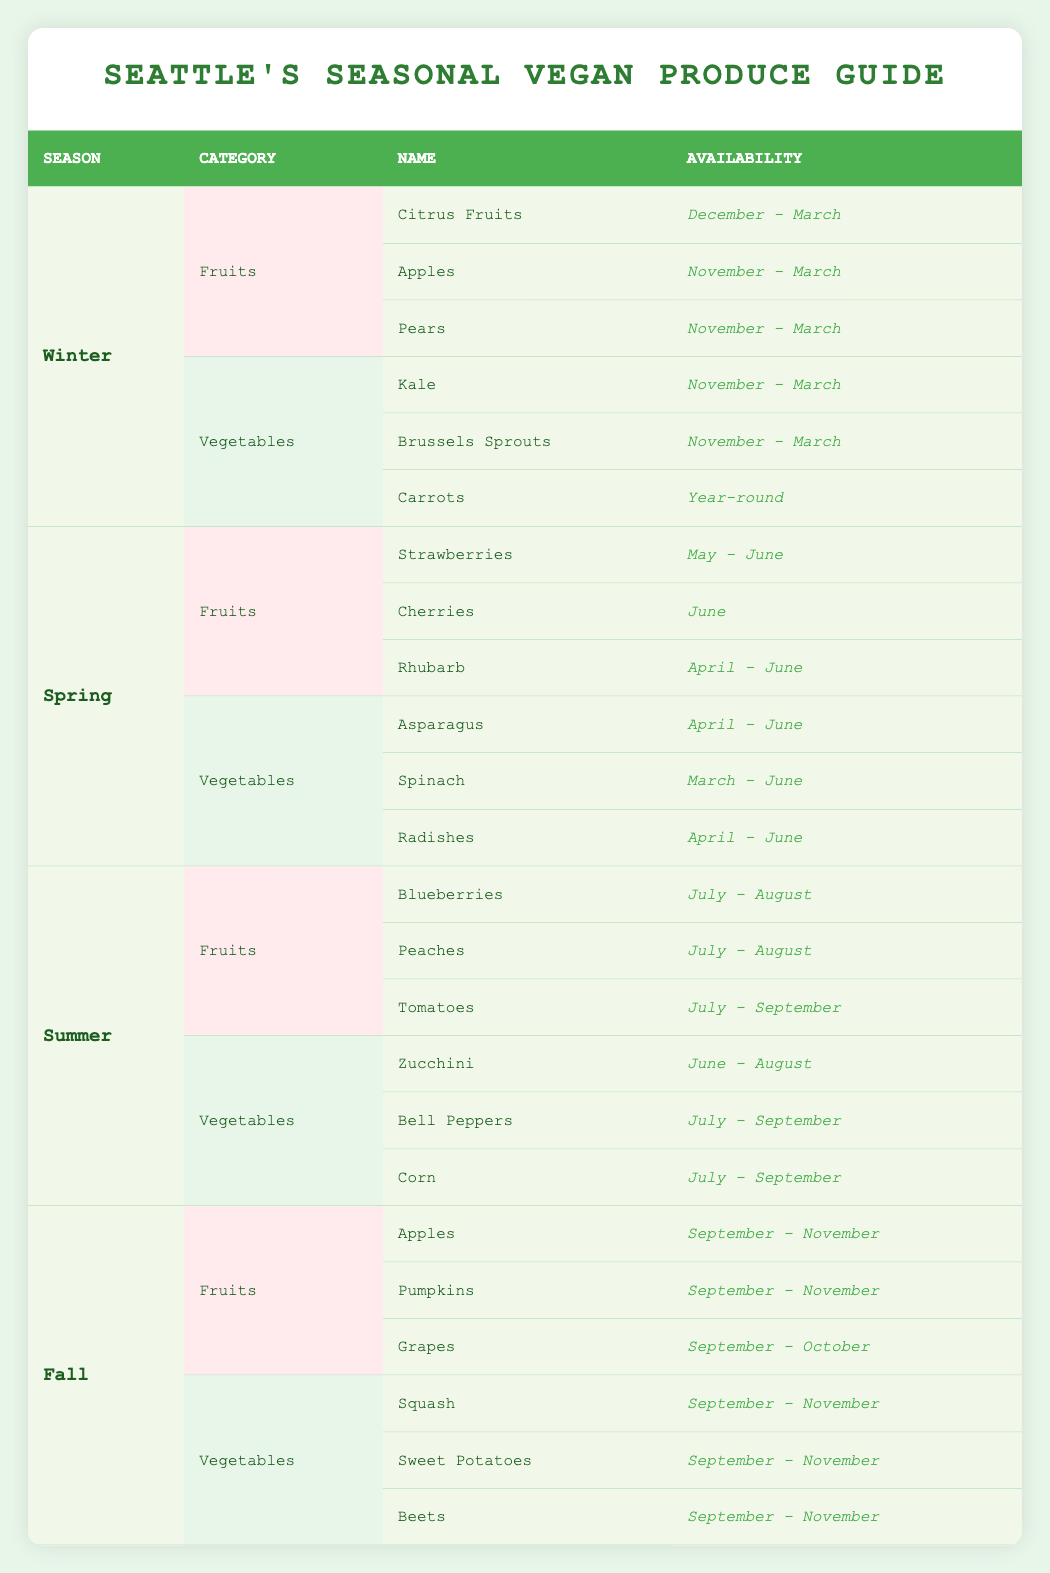What fruits are available in the Winter season? The table lists fruits under the Winter season. The available fruits are Citrus Fruits, Apples, and Pears.
Answer: Citrus Fruits, Apples, Pears Are carrots available year-round? Checking the Vegetables section for Winter, it presents Carrots with the note "Year-round," confirming they are available throughout the year.
Answer: Yes Which season offers the most variety of fruits? By analyzing the fruits available in each season: Winter (3), Spring (3), Summer (3), and Fall (3), all seasons have equal varieties of fruits. Thus, there's no season with more variety than others.
Answer: No season offers more variety How many types of vegetables are available in Spring? In the Vegetables section for Spring, it lists Asparagus, Spinach, and Radishes, totaling 3 types of vegetables.
Answer: 3 Can you find any overlap in fruits available between Winter and Fall? From the fruits in Winter (Citrus Fruits, Apples, Pears) and Fall (Apples, Pumpkins, Grapes), only Apples appear in both seasons.
Answer: Yes, Apples are the overlap What is the availability period for Blueberries? The Summer section lists Blueberries with an availability from July to August.
Answer: July - August In which months are both Cherries and Radishes available? Cherries are available in June, while Radishes are available from April to June. Therefore, the common month is June.
Answer: June Which season has the least number of vegetable types available? Reviewing the Vegetables from each season: Winter (3), Spring (3), Summer (3), and Fall (3). All have an equal count of 3 vegetable types; thus, none has fewer than the others.
Answer: No season has fewer types 